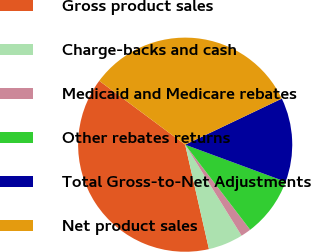Convert chart to OTSL. <chart><loc_0><loc_0><loc_500><loc_500><pie_chart><fcel>Gross product sales<fcel>Charge-backs and cash<fcel>Medicaid and Medicare rebates<fcel>Other rebates returns<fcel>Total Gross-to-Net Adjustments<fcel>Net product sales<nl><fcel>38.74%<fcel>5.27%<fcel>1.55%<fcel>8.99%<fcel>12.71%<fcel>32.75%<nl></chart> 